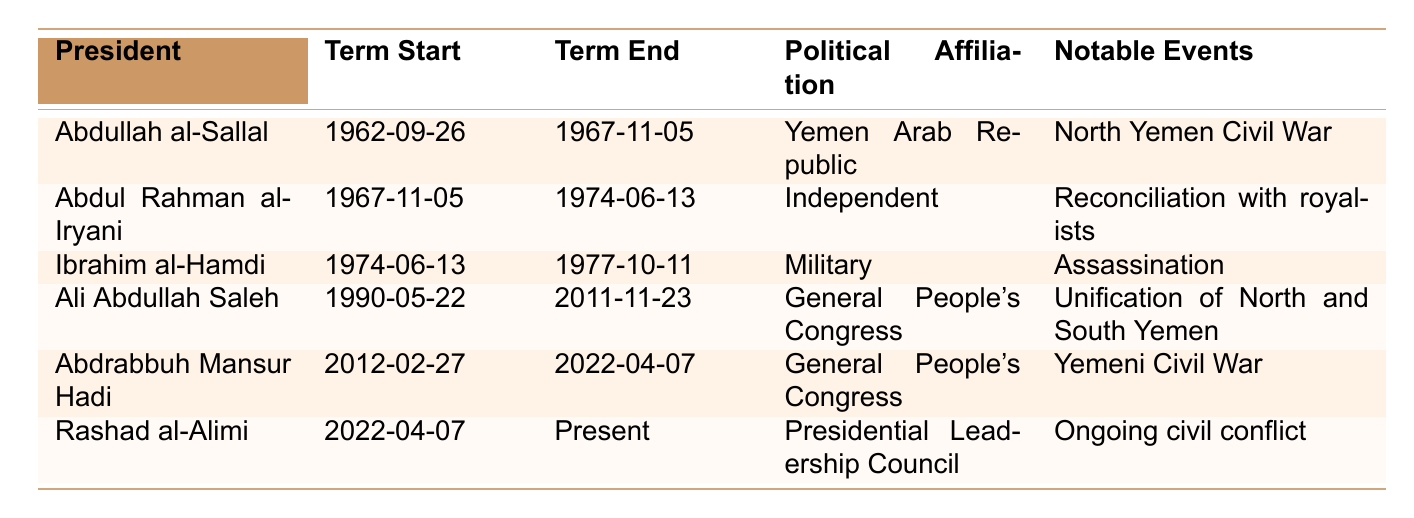What is the political affiliation of Ibrahim al-Hamdi? The table lists Ibrahim al-Hamdi under the "Political Affiliation" column, which shows he was affiliated with the Military.
Answer: Military Who was the president during the North Yemen Civil War? The table indicates that Abdullah al-Sallal served as president during the period of the North Yemen Civil War from 1962 to 1967.
Answer: Abdullah al-Sallal How many years did Ali Abdullah Saleh serve as president? Ali Abdullah Saleh's term started on May 22, 1990, and ended on November 23, 2011. Calculating the duration between these dates, he served for approximately 21 years.
Answer: 21 years What notable event occurred during the term of Abdul Rahman al-Iryani? According to the table, the notable event during Abdul Rahman al-Iryani's term was the reconciliation with royalists, from November 1967 to June 1974.
Answer: Reconciliation with royalists Is Rashad al-Alimi currently serving as president? The term end for Rashad al-Alimi is marked as "Present," indicating he is still serving as president.
Answer: Yes Who had the longest term in office among the listed presidents? By reviewing the term start and end dates, Ali Abdullah Saleh served the longest, from May 22, 1990, to November 23, 2011, totaling 21 years.
Answer: Ali Abdullah Saleh Was there a president who served in the 1970s? The table shows Ibrahim al-Hamdi served as president from June 13, 1974, to October 11, 1977, indicating that there was indeed a president in the 1970s.
Answer: Yes What transitions occurred between the presidencies of Abdul Rahman al-Iryani and Ibrahim al-Hamdi? Abdul Rahman al-Iryani's term ended on June 13, 1974, and Ibrahim al-Hamdi began on the same date, indicating a direct transition with no gap.
Answer: Direct transition During whose presidency did Yemen experience a civil war? Abdrabbuh Mansur Hadi's presidency is noted for the Yemeni Civil War, starting from February 27, 2012, until April 7, 2022.
Answer: Abdrabbuh Mansur Hadi Was the Yemeni Civil War ongoing during Abdul Rahman al-Iryani's presidency? The notable events listed show that the Yemeni Civil War started after Abdul Rahman al-Iryani's presidency; thus, it was not during his term from 1967 to 1974.
Answer: No 